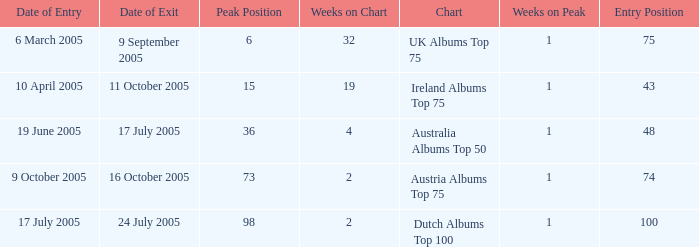What is the date of entry for the UK Albums Top 75 chart? 6 March 2005. 